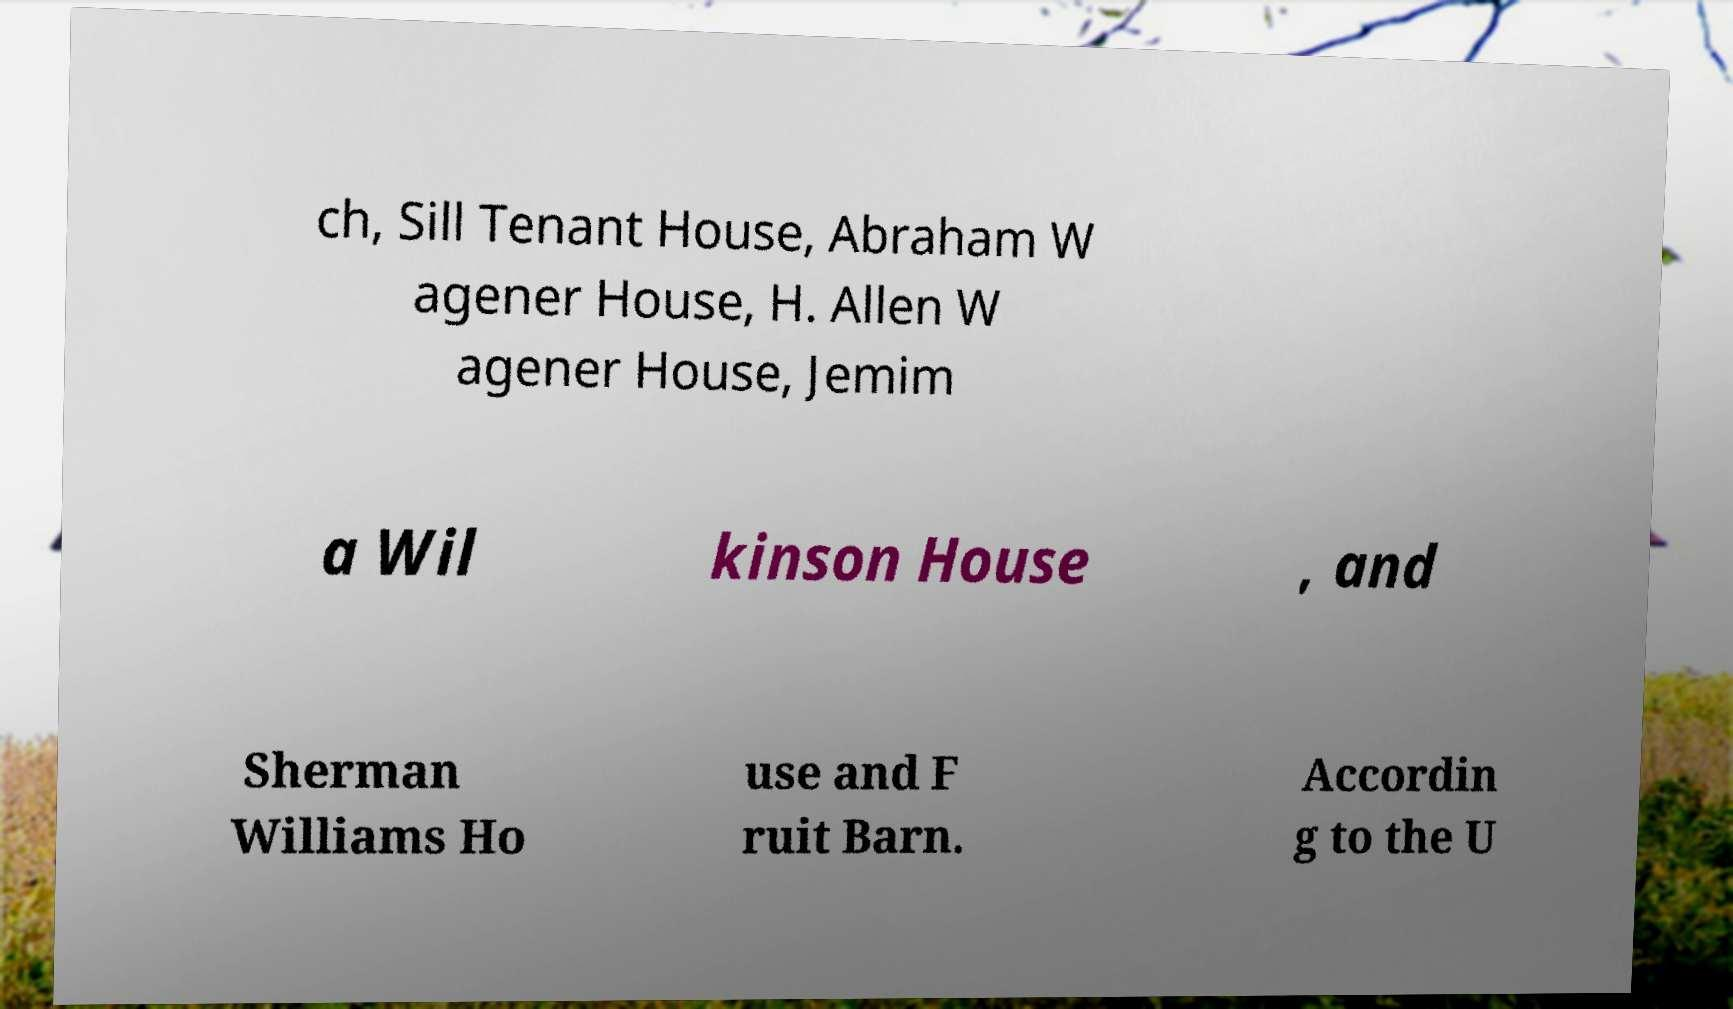For documentation purposes, I need the text within this image transcribed. Could you provide that? ch, Sill Tenant House, Abraham W agener House, H. Allen W agener House, Jemim a Wil kinson House , and Sherman Williams Ho use and F ruit Barn. Accordin g to the U 